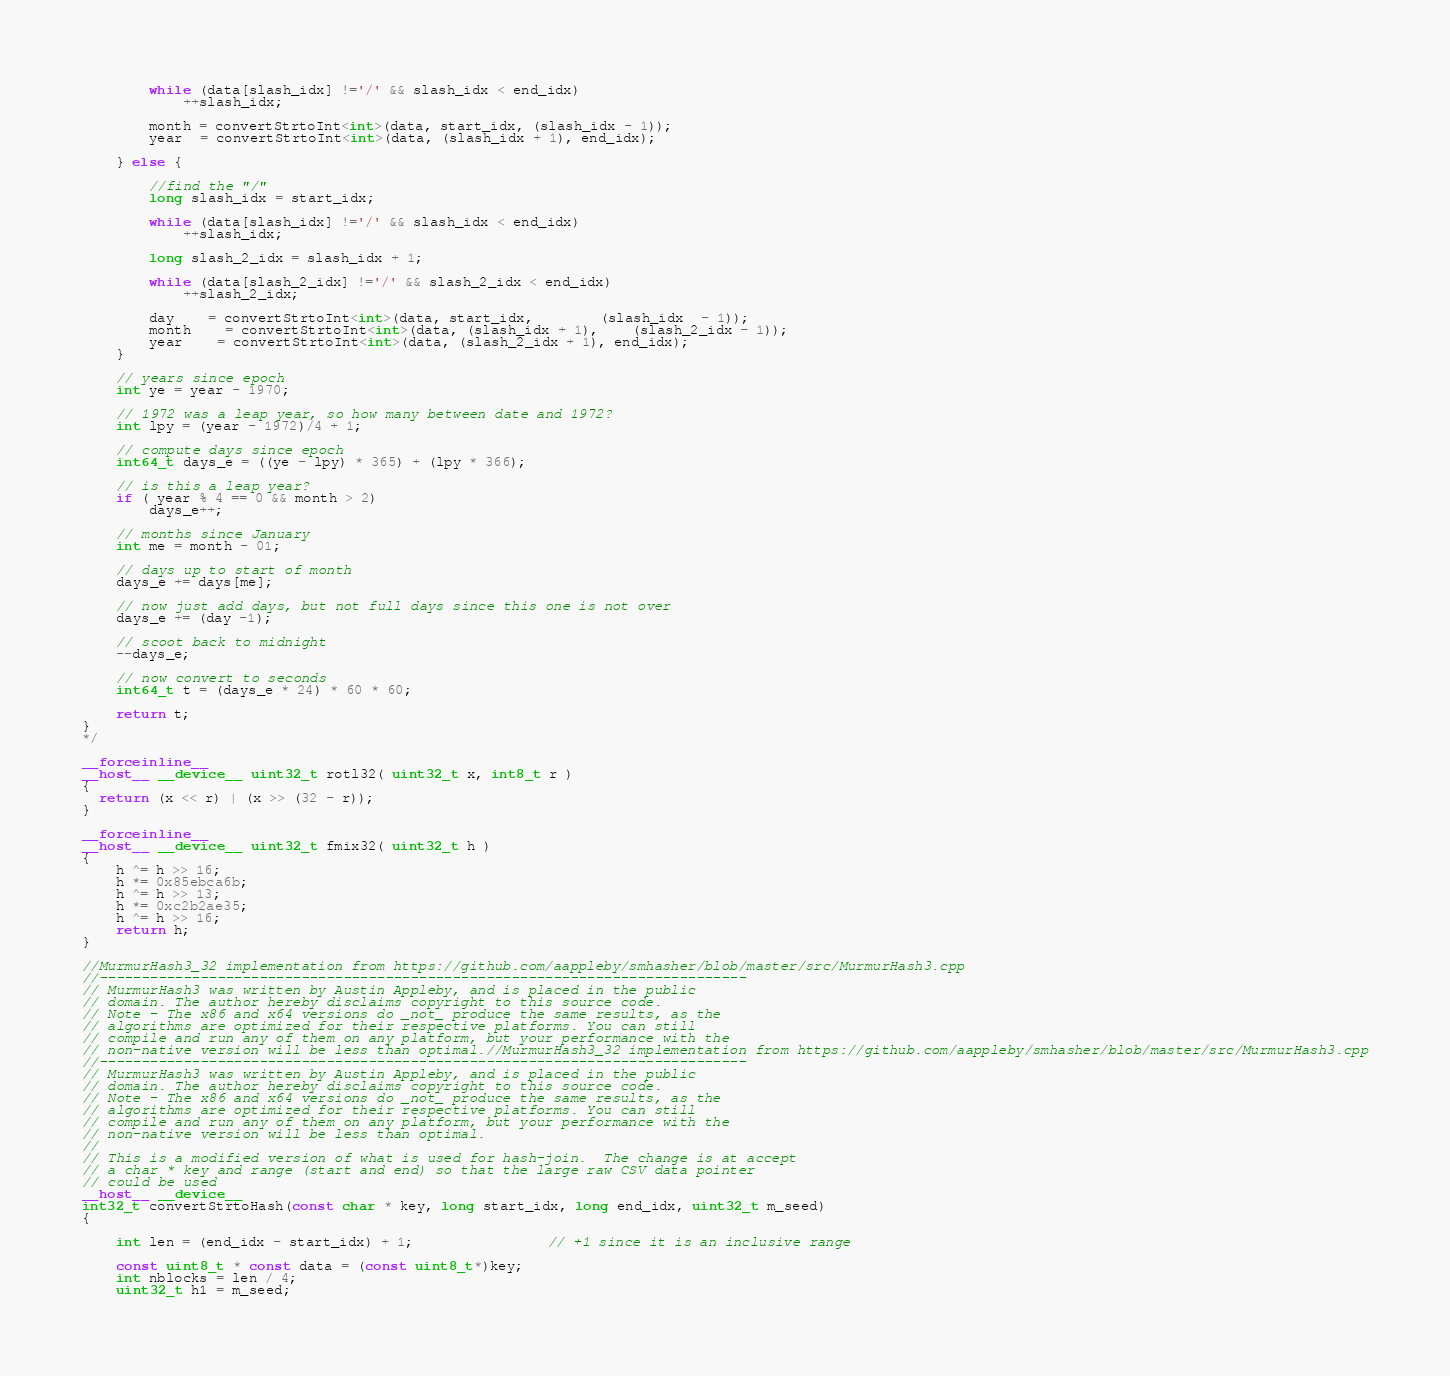Convert code to text. <code><loc_0><loc_0><loc_500><loc_500><_Cuda_>		while (data[slash_idx] !='/' && slash_idx < end_idx)
			++slash_idx;

		month = convertStrtoInt<int>(data, start_idx, (slash_idx - 1));
		year  = convertStrtoInt<int>(data, (slash_idx + 1), end_idx);

	} else {

		//find the "/"
		long slash_idx = start_idx;

		while (data[slash_idx] !='/' && slash_idx < end_idx)
			++slash_idx;

		long slash_2_idx = slash_idx + 1;

		while (data[slash_2_idx] !='/' && slash_2_idx < end_idx)
			++slash_2_idx;

		day 	= convertStrtoInt<int>(data, start_idx, 		(slash_idx  - 1));
		month  	= convertStrtoInt<int>(data, (slash_idx + 1), 	(slash_2_idx - 1));
		year  	= convertStrtoInt<int>(data, (slash_2_idx + 1), end_idx);
	}

	// years since epoch
	int ye = year - 1970;

	// 1972 was a leap year, so how many between date and 1972?
	int lpy = (year - 1972)/4 + 1;

	// compute days since epoch
	int64_t days_e = ((ye - lpy) * 365) + (lpy * 366);

	// is this a leap year?
	if ( year % 4 == 0 && month > 2)
		days_e++;

	// months since January
	int me = month - 01;

	// days up to start of month
	days_e += days[me];

	// now just add days, but not full days since this one is not over
	days_e += (day -1);

	// scoot back to midnight
	--days_e;

	// now convert to seconds
	int64_t t = (days_e * 24) * 60 * 60;

	return t;
}
*/

__forceinline__
__host__ __device__ uint32_t rotl32( uint32_t x, int8_t r )
{
  return (x << r) | (x >> (32 - r));
}

__forceinline__
__host__ __device__ uint32_t fmix32( uint32_t h )
{
    h ^= h >> 16;
    h *= 0x85ebca6b;
    h ^= h >> 13;
    h *= 0xc2b2ae35;
    h ^= h >> 16;
    return h;
}

//MurmurHash3_32 implementation from https://github.com/aappleby/smhasher/blob/master/src/MurmurHash3.cpp
//-----------------------------------------------------------------------------
// MurmurHash3 was written by Austin Appleby, and is placed in the public
// domain. The author hereby disclaims copyright to this source code.
// Note - The x86 and x64 versions do _not_ produce the same results, as the
// algorithms are optimized for their respective platforms. You can still
// compile and run any of them on any platform, but your performance with the
// non-native version will be less than optimal.//MurmurHash3_32 implementation from https://github.com/aappleby/smhasher/blob/master/src/MurmurHash3.cpp
//-----------------------------------------------------------------------------
// MurmurHash3 was written by Austin Appleby, and is placed in the public
// domain. The author hereby disclaims copyright to this source code.
// Note - The x86 and x64 versions do _not_ produce the same results, as the
// algorithms are optimized for their respective platforms. You can still
// compile and run any of them on any platform, but your performance with the
// non-native version will be less than optimal.
//
// This is a modified version of what is used for hash-join.  The change is at accept
// a char * key and range (start and end) so that the large raw CSV data pointer
// could be used
__host__ __device__
int32_t convertStrtoHash(const char * key, long start_idx, long end_idx, uint32_t m_seed)
{

    int len = (end_idx - start_idx) + 1;				// +1 since it is an inclusive range

    const uint8_t * const data = (const uint8_t*)key;
    int nblocks = len / 4;
    uint32_t h1 = m_seed;</code> 